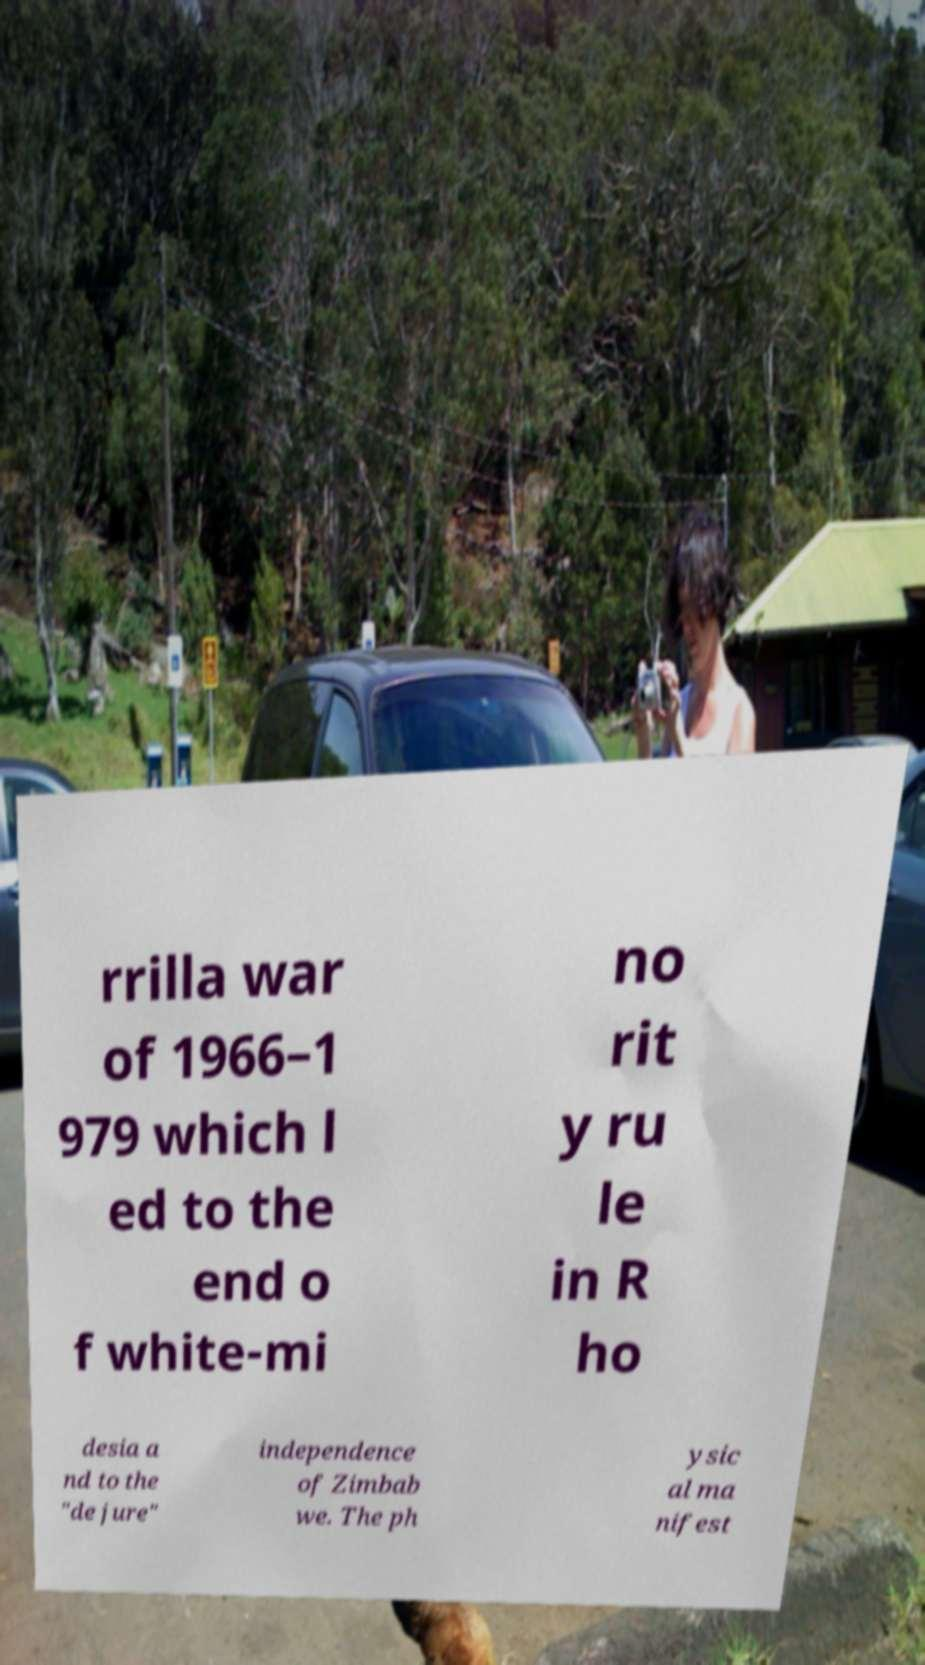Can you read and provide the text displayed in the image?This photo seems to have some interesting text. Can you extract and type it out for me? rrilla war of 1966–1 979 which l ed to the end o f white-mi no rit y ru le in R ho desia a nd to the "de jure" independence of Zimbab we. The ph ysic al ma nifest 